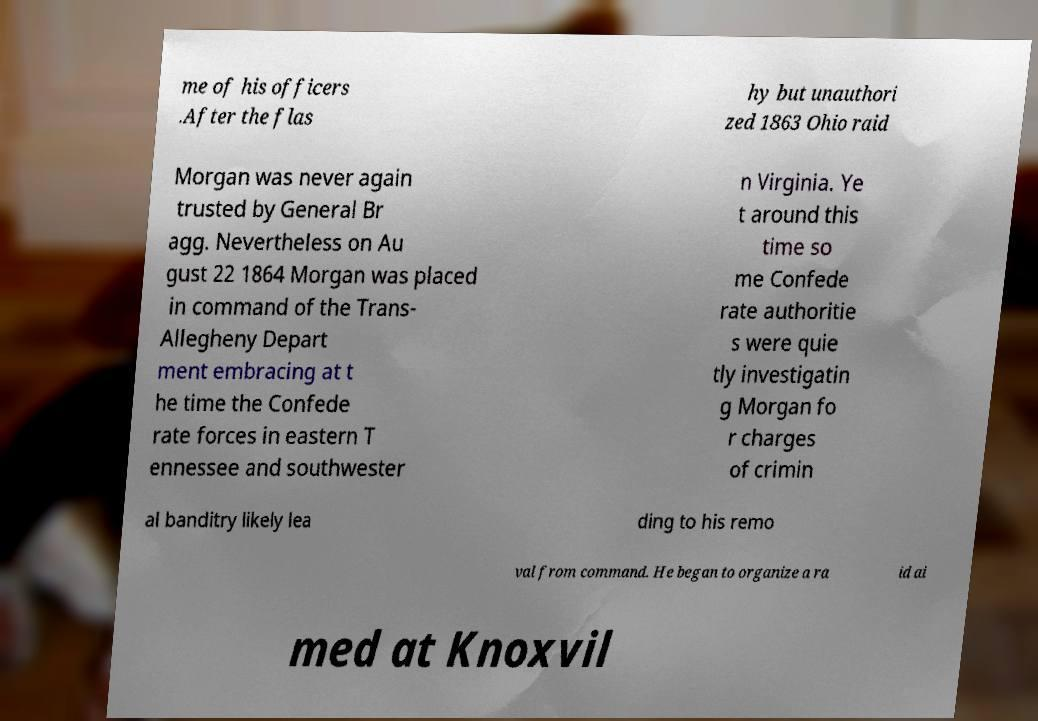Could you extract and type out the text from this image? me of his officers .After the flas hy but unauthori zed 1863 Ohio raid Morgan was never again trusted by General Br agg. Nevertheless on Au gust 22 1864 Morgan was placed in command of the Trans- Allegheny Depart ment embracing at t he time the Confede rate forces in eastern T ennessee and southwester n Virginia. Ye t around this time so me Confede rate authoritie s were quie tly investigatin g Morgan fo r charges of crimin al banditry likely lea ding to his remo val from command. He began to organize a ra id ai med at Knoxvil 